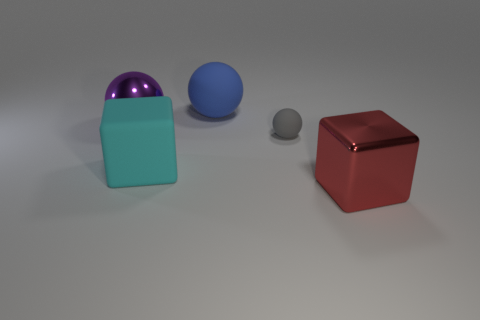Subtract all blue balls. How many balls are left? 2 Add 5 large brown rubber blocks. How many objects exist? 10 Subtract all purple balls. How many balls are left? 2 Subtract all spheres. How many objects are left? 2 Subtract 1 spheres. How many spheres are left? 2 Add 3 tiny gray things. How many tiny gray things exist? 4 Subtract 1 blue balls. How many objects are left? 4 Subtract all cyan cubes. Subtract all green cylinders. How many cubes are left? 1 Subtract all yellow blocks. How many green balls are left? 0 Subtract all large red shiny cubes. Subtract all large blue spheres. How many objects are left? 3 